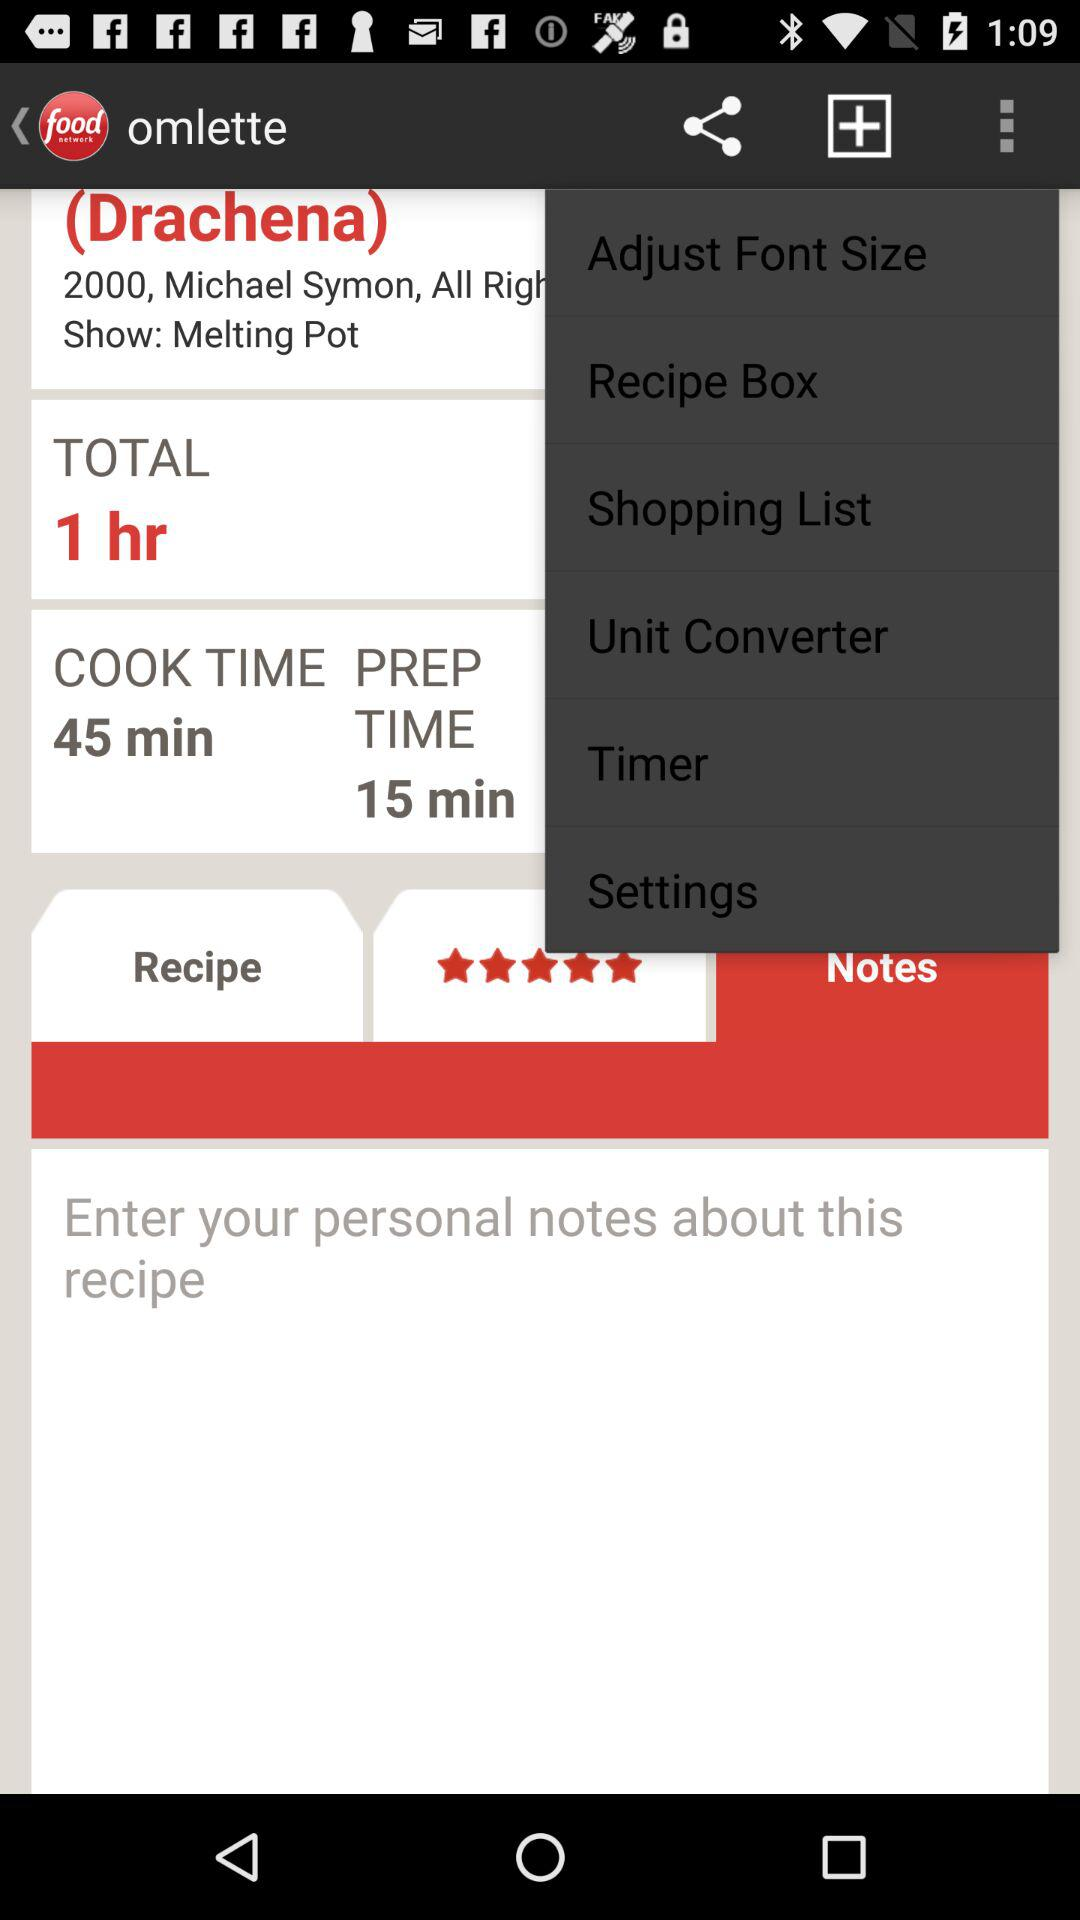What is the rating of the dish? The rating of the dish is 5 stars. 